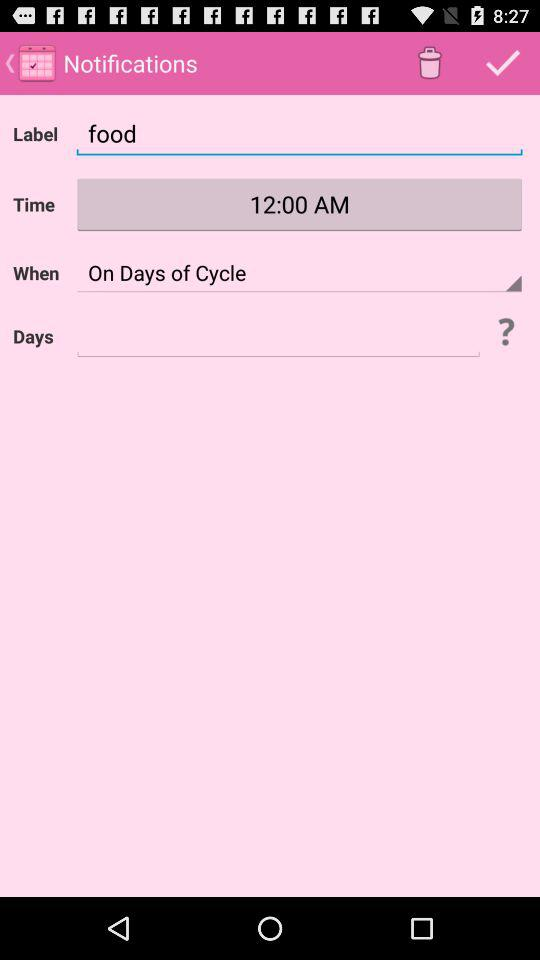What is the time? The time is 12:00 AM. 